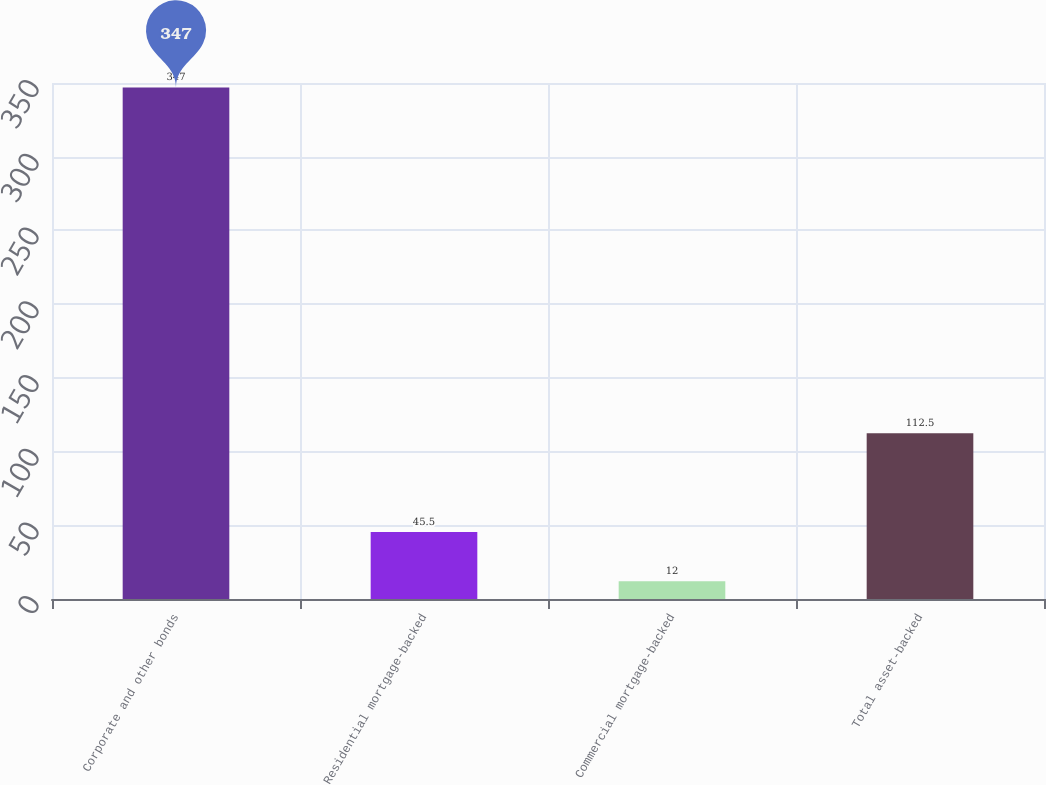Convert chart. <chart><loc_0><loc_0><loc_500><loc_500><bar_chart><fcel>Corporate and other bonds<fcel>Residential mortgage-backed<fcel>Commercial mortgage-backed<fcel>Total asset-backed<nl><fcel>347<fcel>45.5<fcel>12<fcel>112.5<nl></chart> 